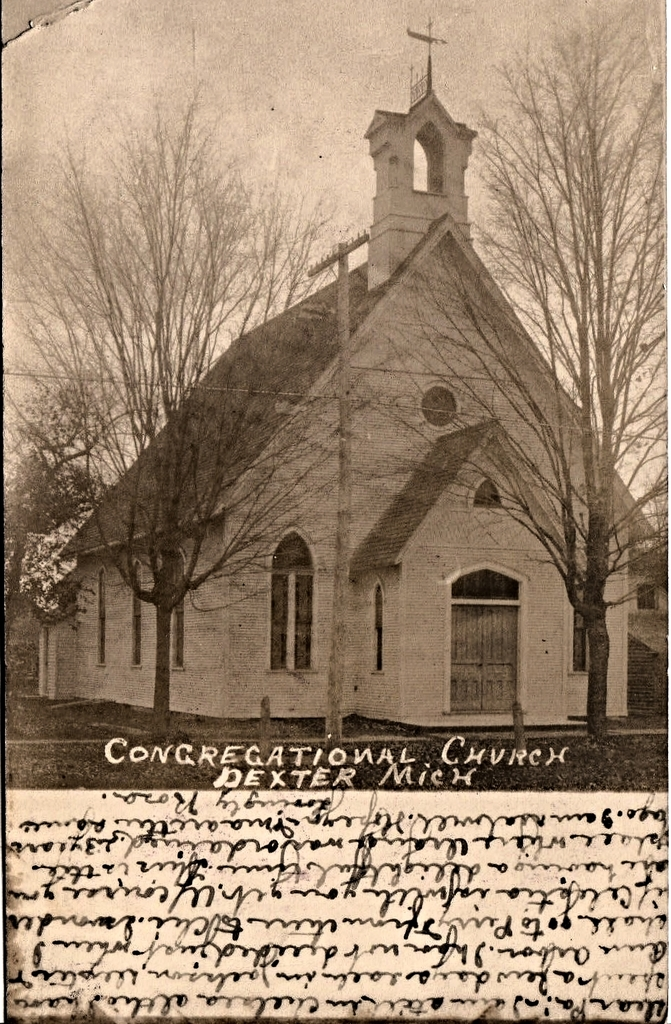Provide a one-sentence caption for the provided image. Vintage photograph depicting the intricate Gothic Revival architecture of the Congregational Church in Dexter, Michigan, showcasing its distinctive arched windows and towering steeple. 